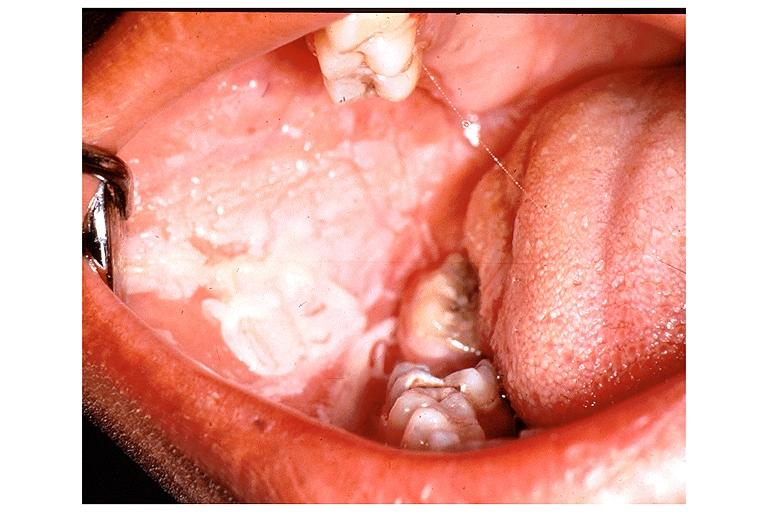s oral present?
Answer the question using a single word or phrase. Yes 